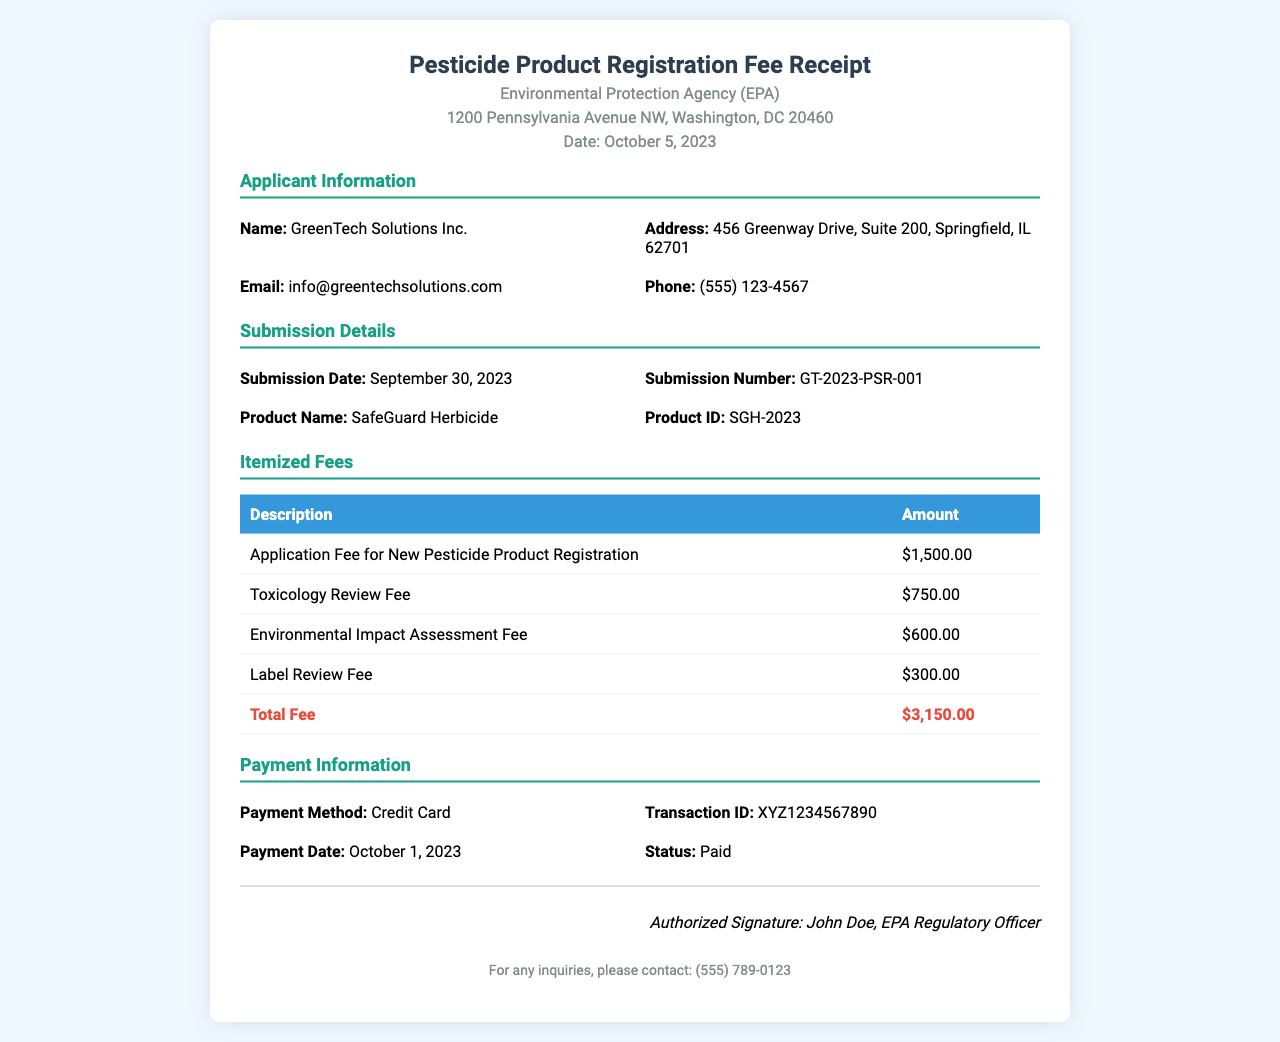What is the total fee for the registration? The total fee is listed at the bottom of the itemized fees table, which combines all fees associated with the registration.
Answer: $3,150.00 Who is the applicant for the pesticide registration? The applicant's name is mentioned in the applicant information section of the document.
Answer: GreenTech Solutions Inc What is the submission date? The submission date is specified in the submission details section.
Answer: September 30, 2023 What is the product name listed in the document? The product name can be found in the submission details section.
Answer: SafeGuard Herbicide What is the transaction ID for the payment? The transaction ID is provided in the payment information section of the document.
Answer: XYZ1234567890 Which fee has the highest amount? The fees are itemized in a table, and the one that stands out with the highest amount is noted therein.
Answer: Application Fee for New Pesticide Product Registration When was the payment made? The payment date is included in the payment information section of the receipt.
Answer: October 1, 2023 What method was used for payment? The payment method is specified in the payment information section.
Answer: Credit Card Who authorized the receipt? The authorized individual's name is mentioned at the bottom of the document as part of the signature section.
Answer: John Doe What is the address of the applicant? The address can be found in the applicant information section of the document.
Answer: 456 Greenway Drive, Suite 200, Springfield, IL 62701 